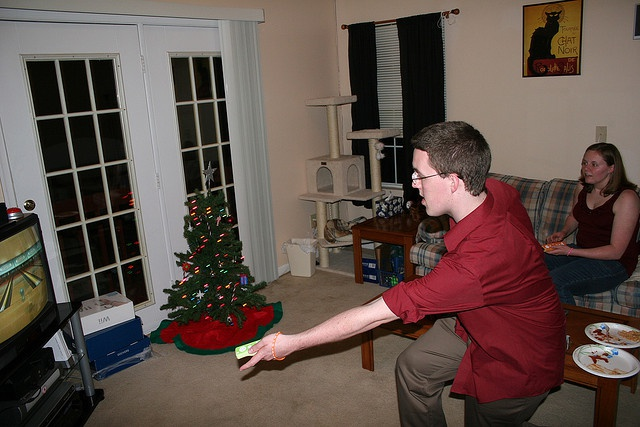Describe the objects in this image and their specific colors. I can see people in gray, maroon, black, and brown tones, people in gray, black, maroon, and brown tones, couch in gray, black, and maroon tones, tv in gray, black, and olive tones, and remote in gray, beige, khaki, and lightgreen tones in this image. 